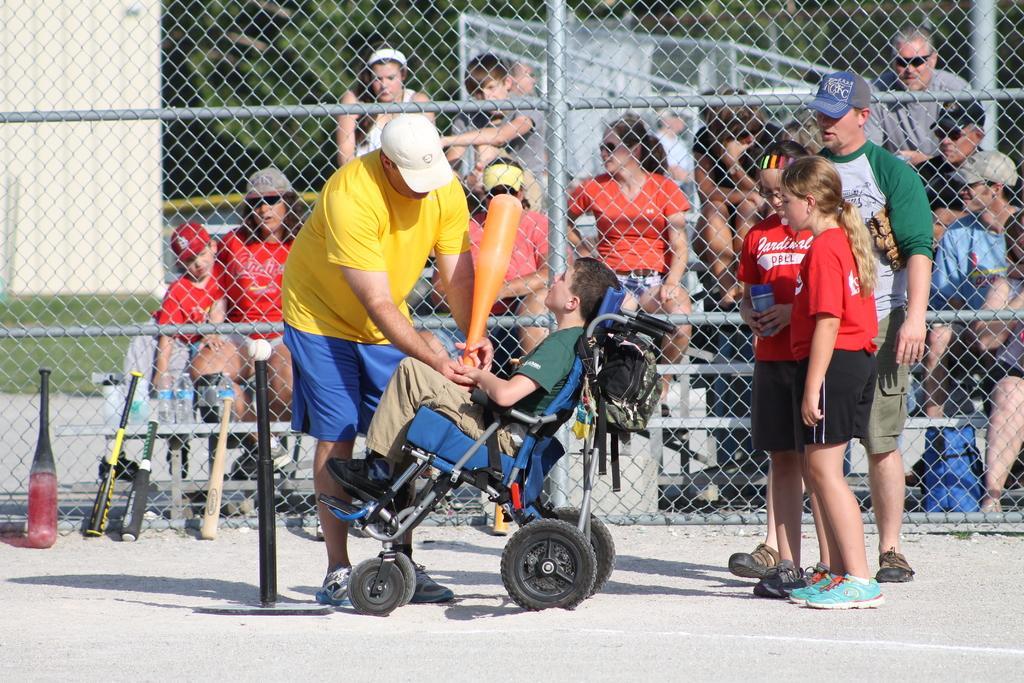Can you describe this image briefly? In this picture we can see a boy in the green t shirt is sitting on a wheelchair and holding and orange base bat. On the left side of the boy there is a man in the yellow t shirt is standing and on the path there are base bats and a pole with a ball. Behind the people there is a fence, trees, bottles and some groups of people are sitting on benches. 